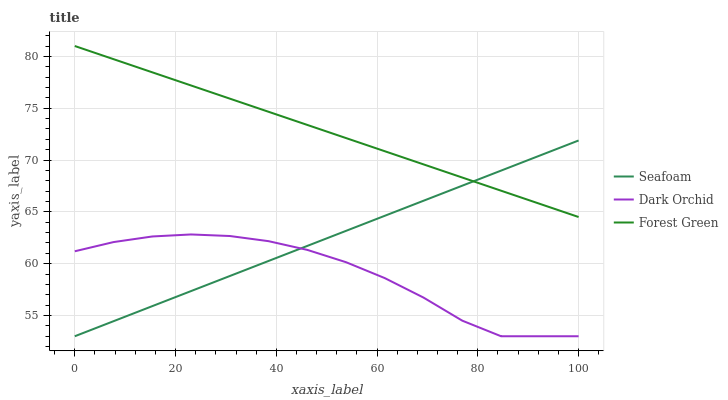Does Dark Orchid have the minimum area under the curve?
Answer yes or no. Yes. Does Forest Green have the maximum area under the curve?
Answer yes or no. Yes. Does Seafoam have the minimum area under the curve?
Answer yes or no. No. Does Seafoam have the maximum area under the curve?
Answer yes or no. No. Is Forest Green the smoothest?
Answer yes or no. Yes. Is Dark Orchid the roughest?
Answer yes or no. Yes. Is Seafoam the smoothest?
Answer yes or no. No. Is Seafoam the roughest?
Answer yes or no. No. Does Seafoam have the lowest value?
Answer yes or no. Yes. Does Forest Green have the highest value?
Answer yes or no. Yes. Does Seafoam have the highest value?
Answer yes or no. No. Is Dark Orchid less than Forest Green?
Answer yes or no. Yes. Is Forest Green greater than Dark Orchid?
Answer yes or no. Yes. Does Seafoam intersect Dark Orchid?
Answer yes or no. Yes. Is Seafoam less than Dark Orchid?
Answer yes or no. No. Is Seafoam greater than Dark Orchid?
Answer yes or no. No. Does Dark Orchid intersect Forest Green?
Answer yes or no. No. 